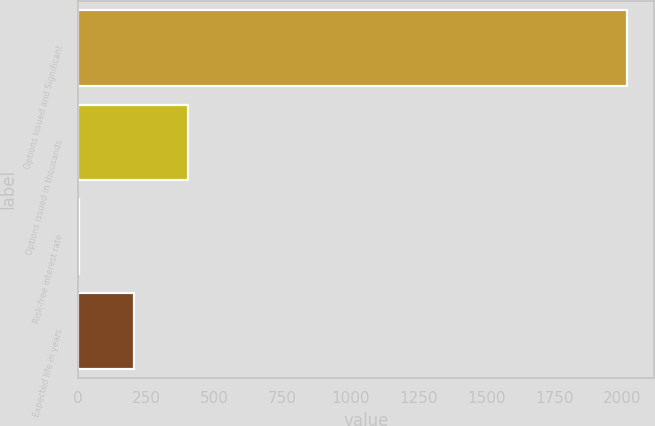<chart> <loc_0><loc_0><loc_500><loc_500><bar_chart><fcel>Options Issued and Significant<fcel>Options issued in thousands<fcel>Risk-free interest rate<fcel>Expected life in years<nl><fcel>2017<fcel>405.16<fcel>2.2<fcel>203.68<nl></chart> 